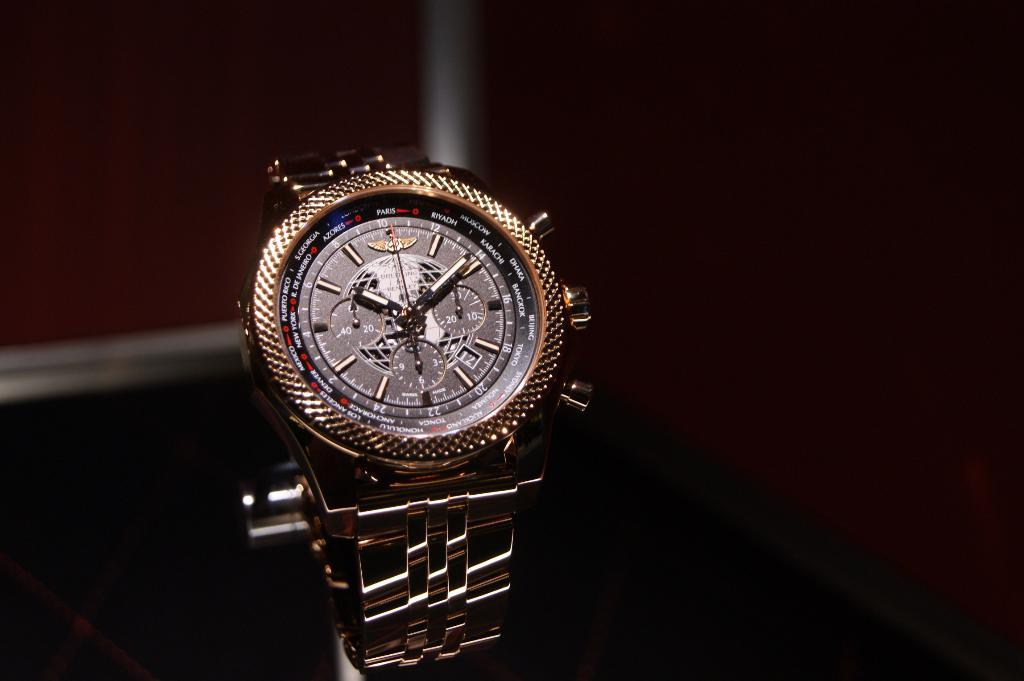<image>
Create a compact narrative representing the image presented. a watch with the numbers 1 to 12 on the front 